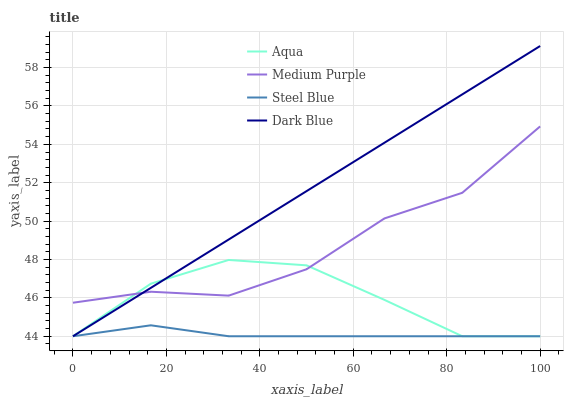Does Steel Blue have the minimum area under the curve?
Answer yes or no. Yes. Does Dark Blue have the maximum area under the curve?
Answer yes or no. Yes. Does Aqua have the minimum area under the curve?
Answer yes or no. No. Does Aqua have the maximum area under the curve?
Answer yes or no. No. Is Dark Blue the smoothest?
Answer yes or no. Yes. Is Medium Purple the roughest?
Answer yes or no. Yes. Is Aqua the smoothest?
Answer yes or no. No. Is Aqua the roughest?
Answer yes or no. No. Does Dark Blue have the lowest value?
Answer yes or no. Yes. Does Dark Blue have the highest value?
Answer yes or no. Yes. Does Aqua have the highest value?
Answer yes or no. No. Is Steel Blue less than Medium Purple?
Answer yes or no. Yes. Is Medium Purple greater than Steel Blue?
Answer yes or no. Yes. Does Dark Blue intersect Medium Purple?
Answer yes or no. Yes. Is Dark Blue less than Medium Purple?
Answer yes or no. No. Is Dark Blue greater than Medium Purple?
Answer yes or no. No. Does Steel Blue intersect Medium Purple?
Answer yes or no. No. 